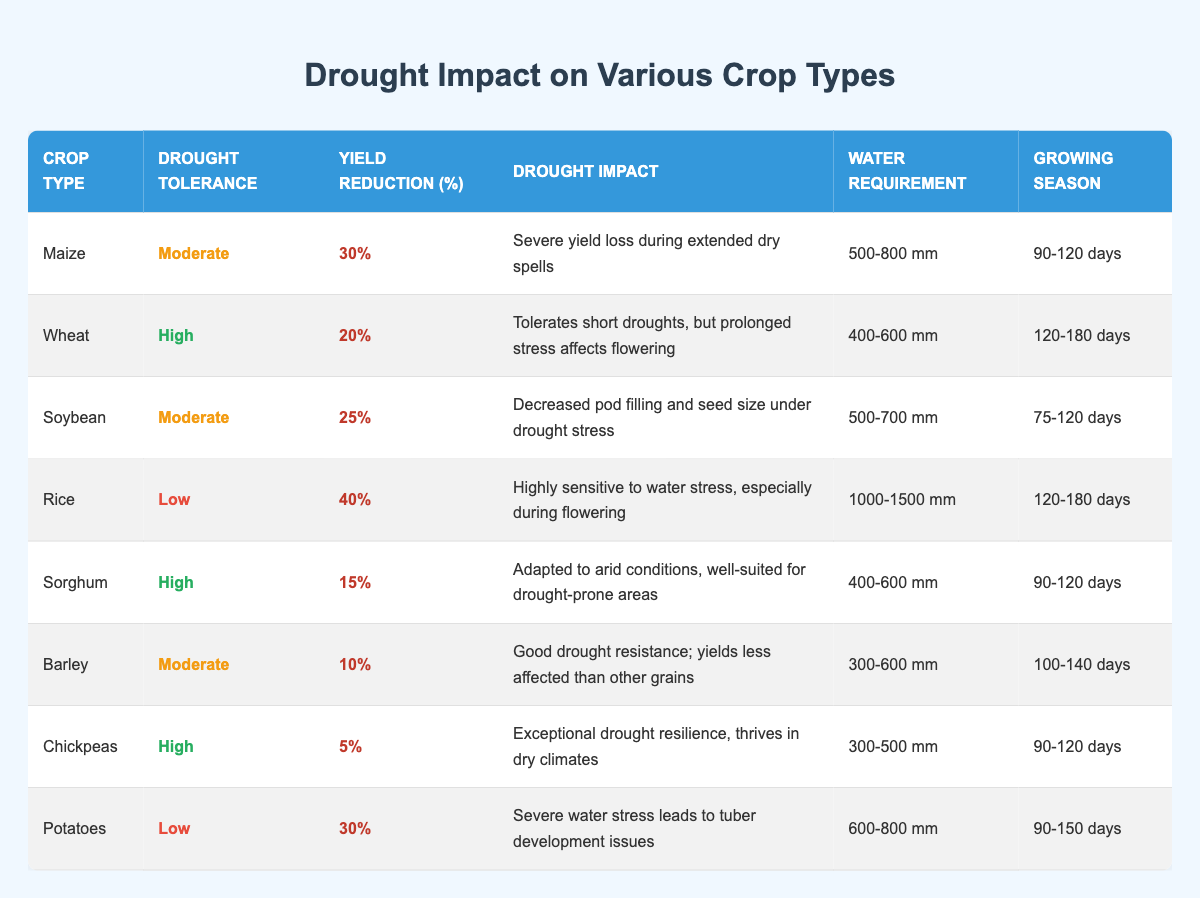What is the yield reduction percentage for Rice? In the table, the row corresponding to Rice states that the yield reduction percentage is 40%.
Answer: 40% Which crop has the highest drought tolerance? Looking at the drought tolerance column, both Wheat, Sorghum, and Chickpeas are marked as having high drought tolerance.
Answer: Wheat, Sorghum, Chickpeas What is the water requirement for Chickpeas? From the table, the water requirement listed for Chickpeas is 300-500 mm.
Answer: 300-500 mm What crop type experiences a yield reduction of 30%? By examining the yield reduction percentage column, both Maize and Potatoes show a yield reduction of 30%.
Answer: Maize, Potatoes What is the average yield reduction percentage for the crops with low drought tolerance? The crops with low drought tolerance are Rice (40%) and Potatoes (30%). Summing these values gives 70%, and dividing by 2 (the number of crops) gives an average of 35%.
Answer: 35% Is it true that Sorghum has a yield reduction percentage of more than 15%? In the table, Sorghum's yield reduction percentage is listed as 15%, which means it is not more than 15%.
Answer: No Which crop type has the least yield reduction percentage? The table indicates that Chickpeas have the least yield reduction percentage at 5%.
Answer: Chickpeas Which crop types are adapted to arid conditions? The table shows that Sorghum and Chickpeas are both described as well-suited for drought-prone areas and have high drought tolerance, indicating their adaptation to arid conditions.
Answer: Sorghum, Chickpeas Is the water requirement for Maize more than 600 mm? The table states that the water requirement for Maize is between 500-800 mm, which indicates that it can indeed require more than 600 mm at its maximum.
Answer: Yes 